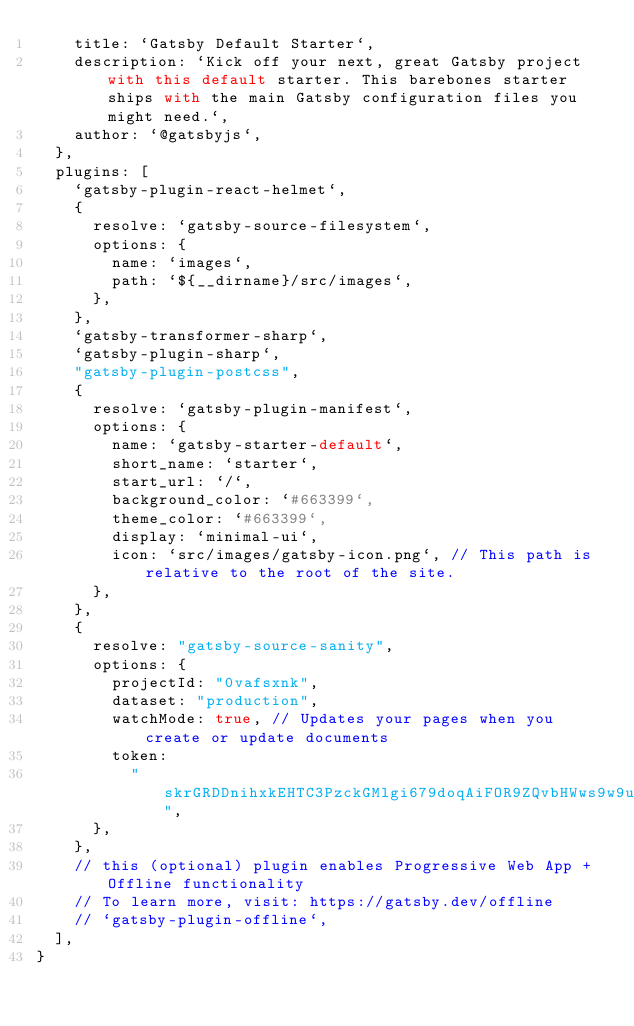Convert code to text. <code><loc_0><loc_0><loc_500><loc_500><_JavaScript_>    title: `Gatsby Default Starter`,
    description: `Kick off your next, great Gatsby project with this default starter. This barebones starter ships with the main Gatsby configuration files you might need.`,
    author: `@gatsbyjs`,
  },
  plugins: [
    `gatsby-plugin-react-helmet`,
    {
      resolve: `gatsby-source-filesystem`,
      options: {
        name: `images`,
        path: `${__dirname}/src/images`,
      },
    },
    `gatsby-transformer-sharp`,
    `gatsby-plugin-sharp`,
    "gatsby-plugin-postcss",
    {
      resolve: `gatsby-plugin-manifest`,
      options: {
        name: `gatsby-starter-default`,
        short_name: `starter`,
        start_url: `/`,
        background_color: `#663399`,
        theme_color: `#663399`,
        display: `minimal-ui`,
        icon: `src/images/gatsby-icon.png`, // This path is relative to the root of the site.
      },
    },
    {
      resolve: "gatsby-source-sanity",
      options: {
        projectId: "0vafsxnk",
        dataset: "production",
        watchMode: true, // Updates your pages when you create or update documents
        token:
          "skrGRDDnihxkEHTC3PzckGMlgi679doqAiFOR9ZQvbHWws9w9uzrWAYP5EuwK0zDrlDSVlPdZkBAYMvY3s4CpkGGTitJ6bLJOf5FKWrx4vbNJNHH2iyqwocmqtrPVjAG1PXo8Hyaz93pxNTcYOoInfndzE2G137qeV9mTp1LT3H5WXlSoi9O",
      },
    },
    // this (optional) plugin enables Progressive Web App + Offline functionality
    // To learn more, visit: https://gatsby.dev/offline
    // `gatsby-plugin-offline`,
  ],
}
</code> 